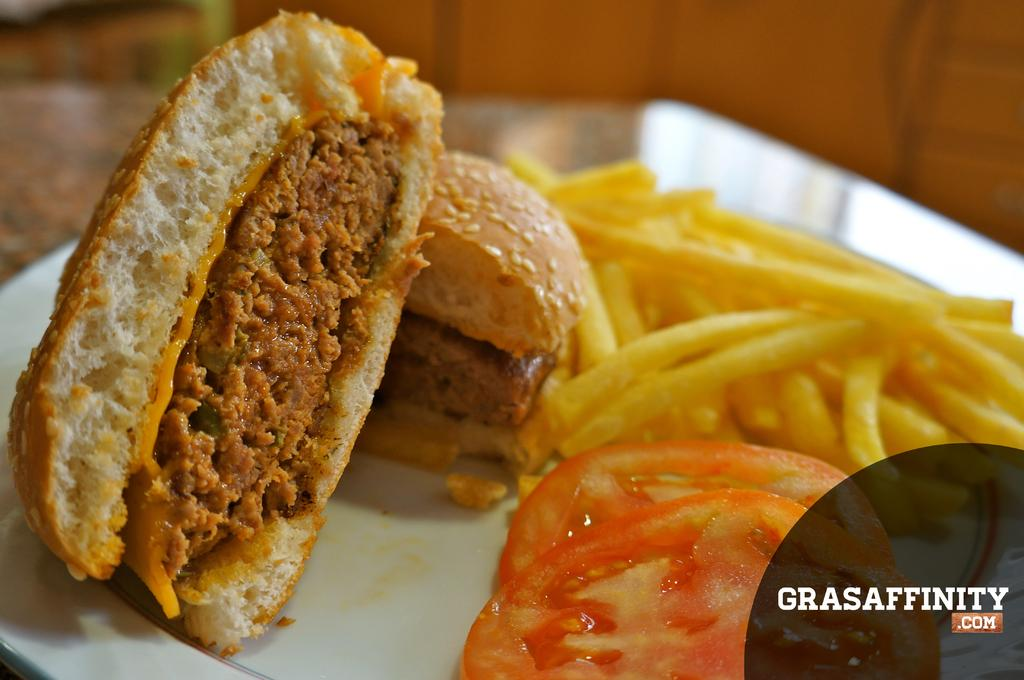What is placed in the tray that is visible in the image? There are food items placed in a tray in the image. Besides the food items, what else can be seen in the image? There is some text in the right corner of the image. Where is the sink located in the image? There is no sink present in the image. What error can be seen in the text in the image? There is no error in the text in the image, as the provided facts do not mention any errors. 